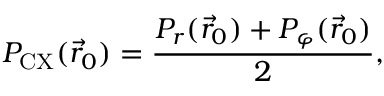<formula> <loc_0><loc_0><loc_500><loc_500>P _ { C X } ( \vec { r } _ { 0 } ) = \frac { P _ { r } ( \vec { r } _ { 0 } ) + P _ { \varphi } ( \vec { r } _ { 0 } ) } { 2 } ,</formula> 